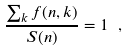Convert formula to latex. <formula><loc_0><loc_0><loc_500><loc_500>\frac { \sum _ { k } f ( n , k ) } { S ( n ) } = 1 \ ,</formula> 